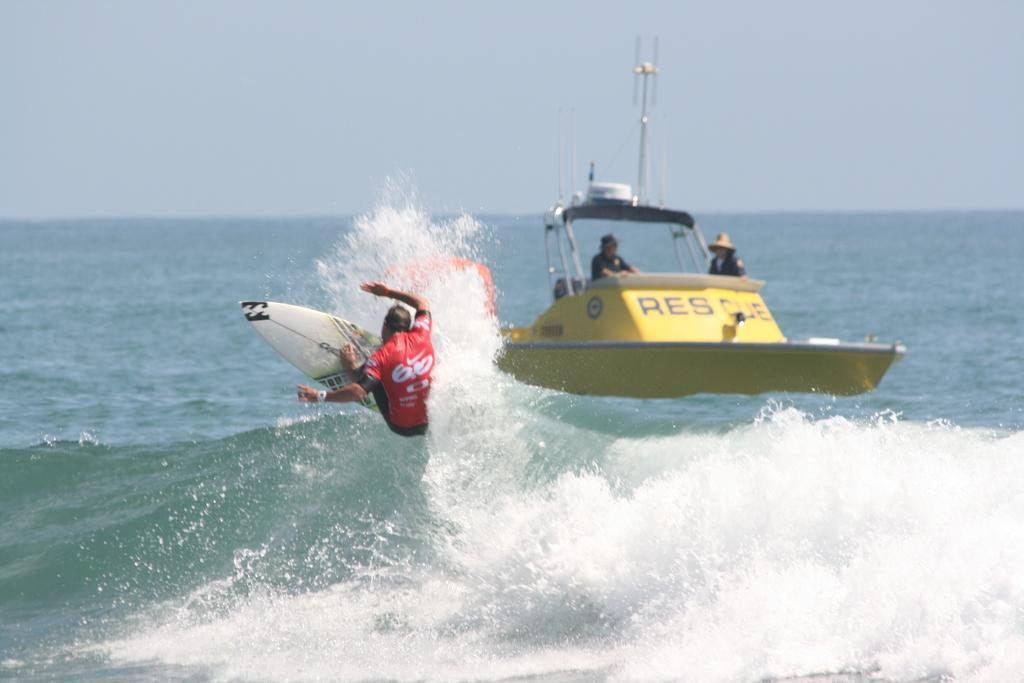<image>
Render a clear and concise summary of the photo. A ma nriding a surf board while a yellow boat that says resque rides past him. 